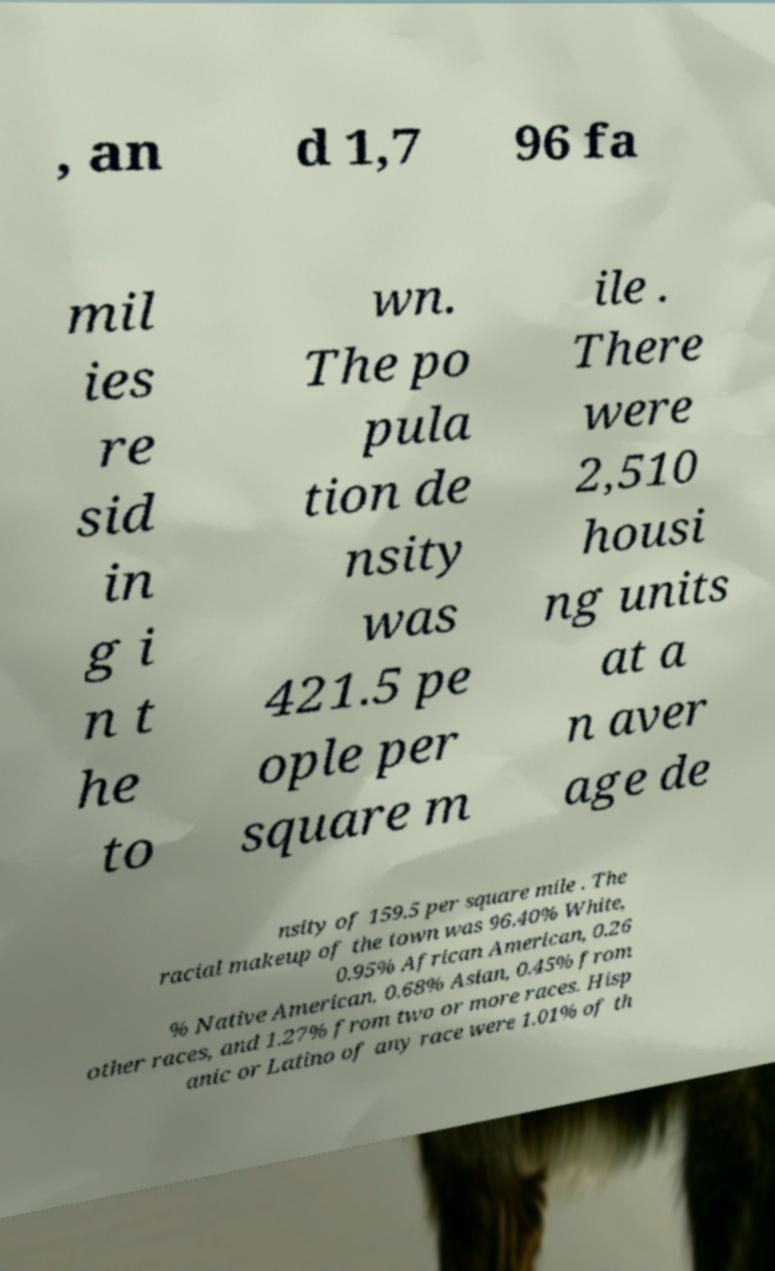Could you assist in decoding the text presented in this image and type it out clearly? , an d 1,7 96 fa mil ies re sid in g i n t he to wn. The po pula tion de nsity was 421.5 pe ople per square m ile . There were 2,510 housi ng units at a n aver age de nsity of 159.5 per square mile . The racial makeup of the town was 96.40% White, 0.95% African American, 0.26 % Native American, 0.68% Asian, 0.45% from other races, and 1.27% from two or more races. Hisp anic or Latino of any race were 1.01% of th 